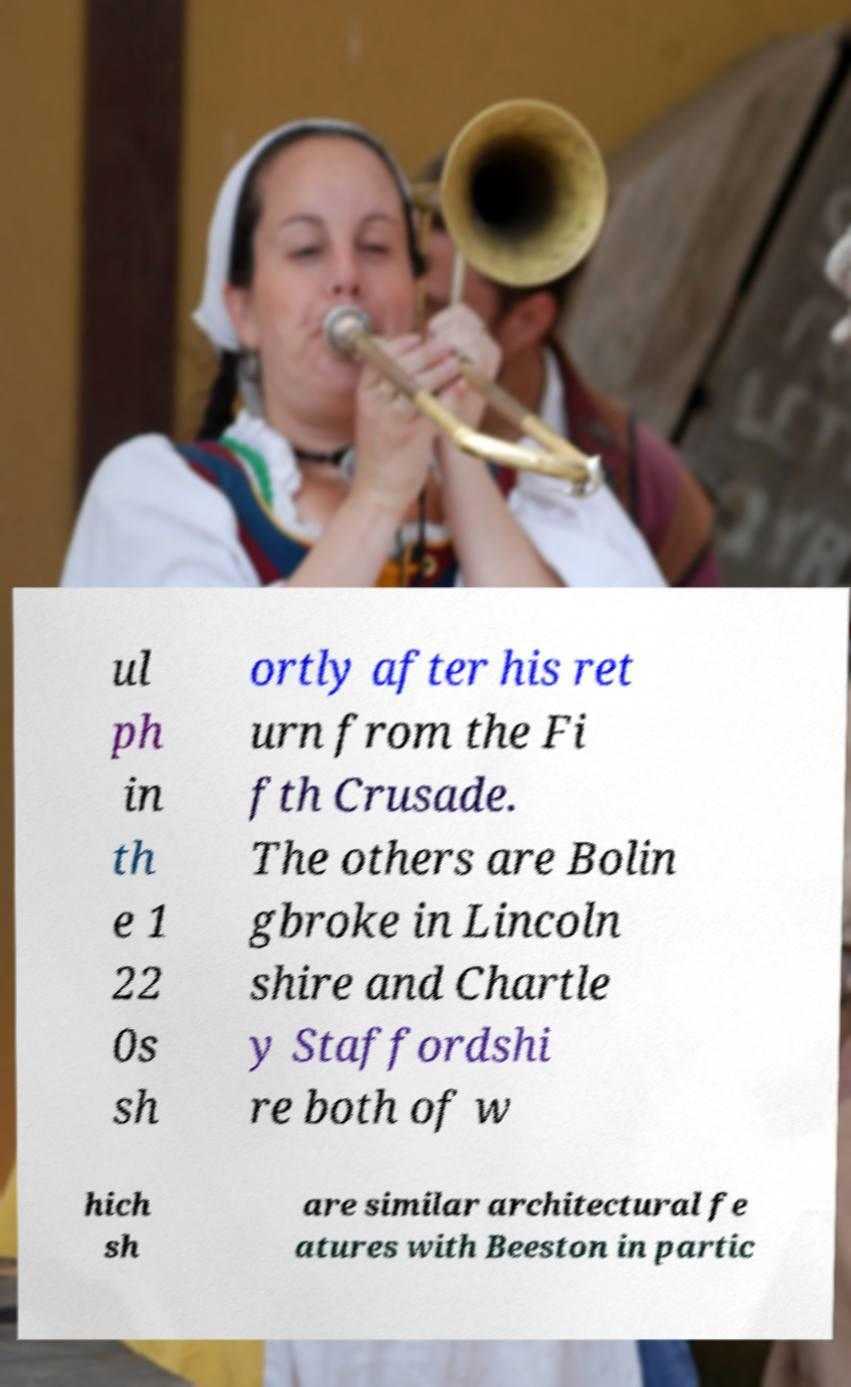Can you accurately transcribe the text from the provided image for me? ul ph in th e 1 22 0s sh ortly after his ret urn from the Fi fth Crusade. The others are Bolin gbroke in Lincoln shire and Chartle y Staffordshi re both of w hich sh are similar architectural fe atures with Beeston in partic 